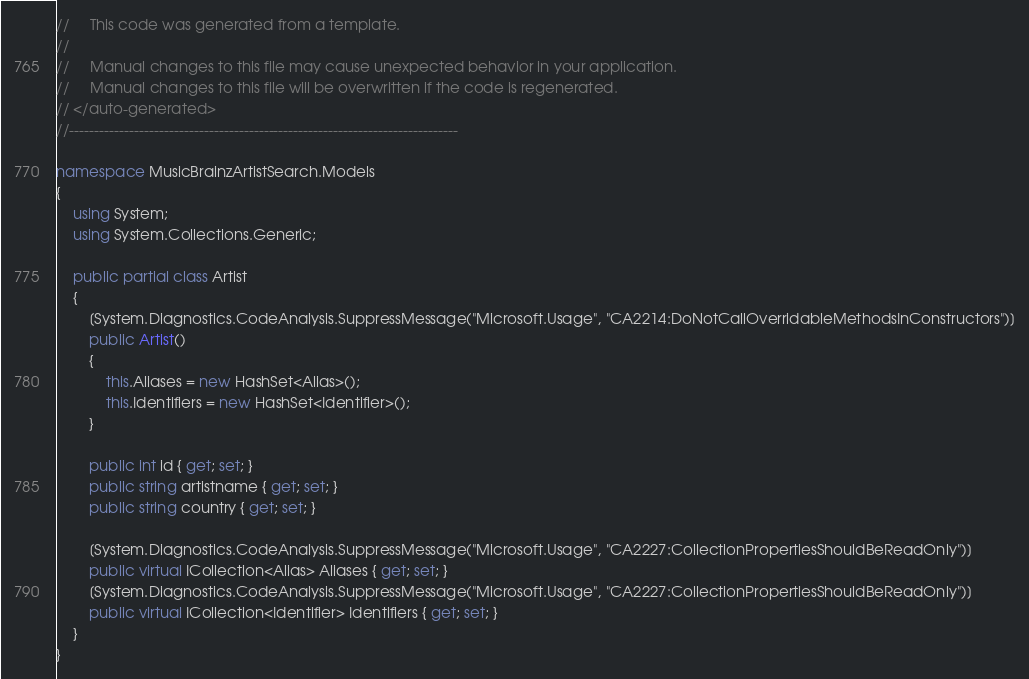<code> <loc_0><loc_0><loc_500><loc_500><_C#_>//     This code was generated from a template.
//
//     Manual changes to this file may cause unexpected behavior in your application.
//     Manual changes to this file will be overwritten if the code is regenerated.
// </auto-generated>
//------------------------------------------------------------------------------

namespace MusicBrainzArtistSearch.Models
{
    using System;
    using System.Collections.Generic;
    
    public partial class Artist
    {
        [System.Diagnostics.CodeAnalysis.SuppressMessage("Microsoft.Usage", "CA2214:DoNotCallOverridableMethodsInConstructors")]
        public Artist()
        {
            this.Aliases = new HashSet<Alias>();
            this.Identifiers = new HashSet<Identifier>();
        }
    
        public int id { get; set; }
        public string artistname { get; set; }
        public string country { get; set; }
    
        [System.Diagnostics.CodeAnalysis.SuppressMessage("Microsoft.Usage", "CA2227:CollectionPropertiesShouldBeReadOnly")]
        public virtual ICollection<Alias> Aliases { get; set; }
        [System.Diagnostics.CodeAnalysis.SuppressMessage("Microsoft.Usage", "CA2227:CollectionPropertiesShouldBeReadOnly")]
        public virtual ICollection<Identifier> Identifiers { get; set; }
    }
}
</code> 